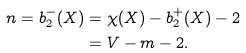<formula> <loc_0><loc_0><loc_500><loc_500>n = b _ { 2 } ^ { - } ( X ) & = \chi ( X ) - b _ { 2 } ^ { + } ( X ) - 2 \\ & = V - m - 2 .</formula> 